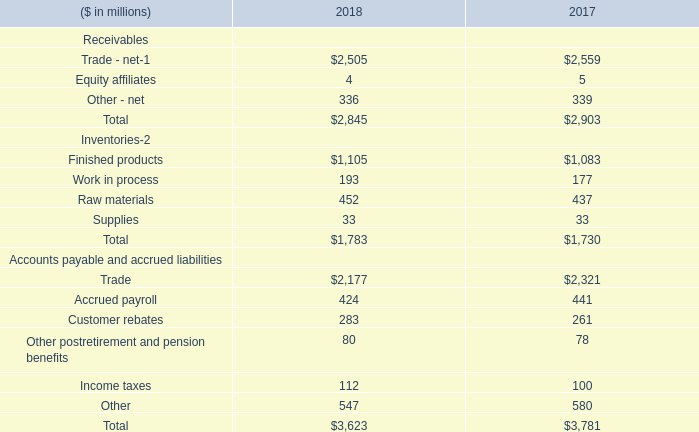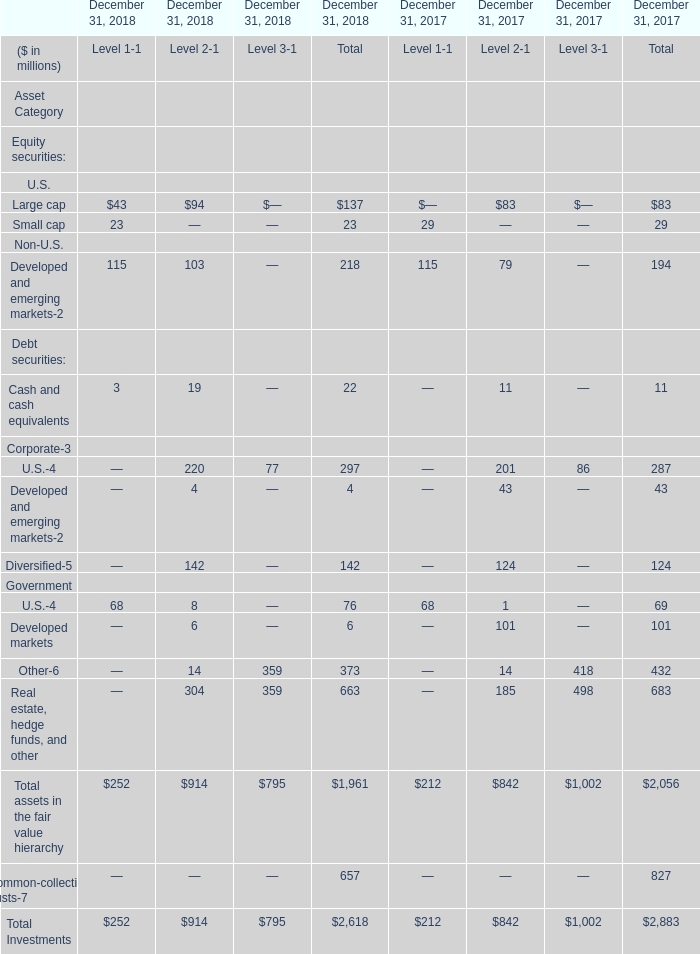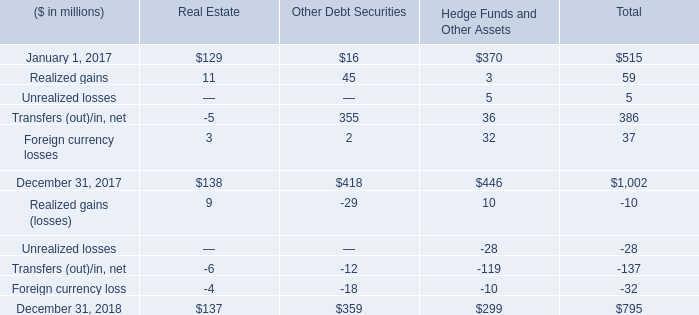At December 31, 2018, the Total assets in the fair value hierarchy of which Level ranks first? 
Answer: 2. 